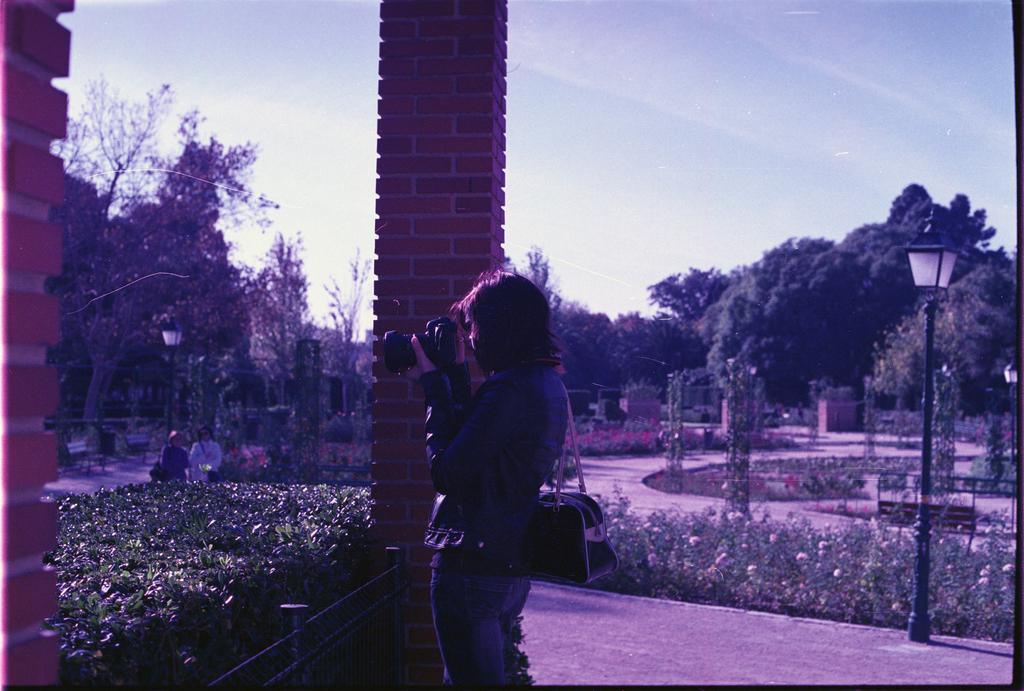What is the woman in the image holding? The woman is holding a camera in the image. Can you describe the other people in the image? There are people in the image, but their specific actions or features are not mentioned in the facts. What type of vegetation is present in the image? There are plants and trees in the image. What architectural structures can be seen in the image? There are pillories in the image. Where is the drain located in the image? There is no drain present in the image. What type of lumber is being used to construct the pillories in the image? There is no mention of lumber or the construction of the pillories in the image. 